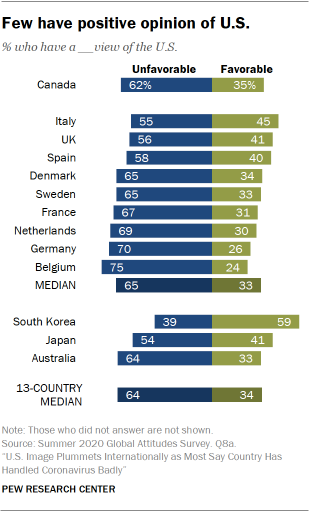Identify some key points in this picture. The sum of the two largest green bars is greater than the sum of two bars in Canada. According to the data, 0.41% of the Japanese population hold a favorable view of the US. 